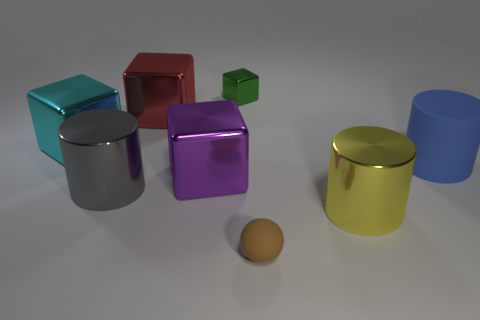How many other objects are there of the same color as the small metal block?
Provide a succinct answer. 0. Does the cube in front of the large blue rubber thing have the same material as the brown ball in front of the large blue cylinder?
Give a very brief answer. No. How many objects are either big metal objects on the left side of the gray metal thing or metallic cylinders that are left of the tiny green block?
Provide a succinct answer. 2. Is there anything else that is the same shape as the brown matte thing?
Your response must be concise. No. What number of small cyan cylinders are there?
Provide a succinct answer. 0. Is there a gray metallic cylinder of the same size as the cyan shiny object?
Ensure brevity in your answer.  Yes. Is the small brown sphere made of the same material as the block on the right side of the purple shiny cube?
Provide a short and direct response. No. What is the cylinder that is to the left of the purple metal object made of?
Keep it short and to the point. Metal. How big is the cyan metallic thing?
Provide a succinct answer. Large. There is a cylinder behind the big purple shiny object; is its size the same as the metal cylinder that is to the left of the yellow metallic thing?
Make the answer very short. Yes. 